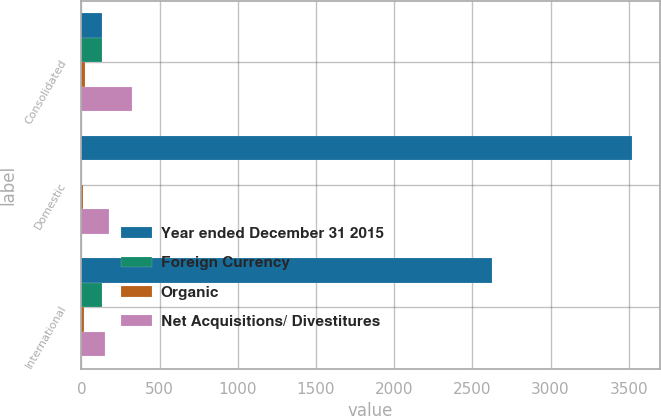<chart> <loc_0><loc_0><loc_500><loc_500><stacked_bar_chart><ecel><fcel>Consolidated<fcel>Domestic<fcel>International<nl><fcel>Year ended December 31 2015<fcel>128.8<fcel>3520.8<fcel>2624.6<nl><fcel>Foreign Currency<fcel>128.8<fcel>0<fcel>128.8<nl><fcel>Organic<fcel>21.7<fcel>7.7<fcel>14<nl><fcel>Net Acquisitions/ Divestitures<fcel>324.5<fcel>175.6<fcel>148.9<nl></chart> 